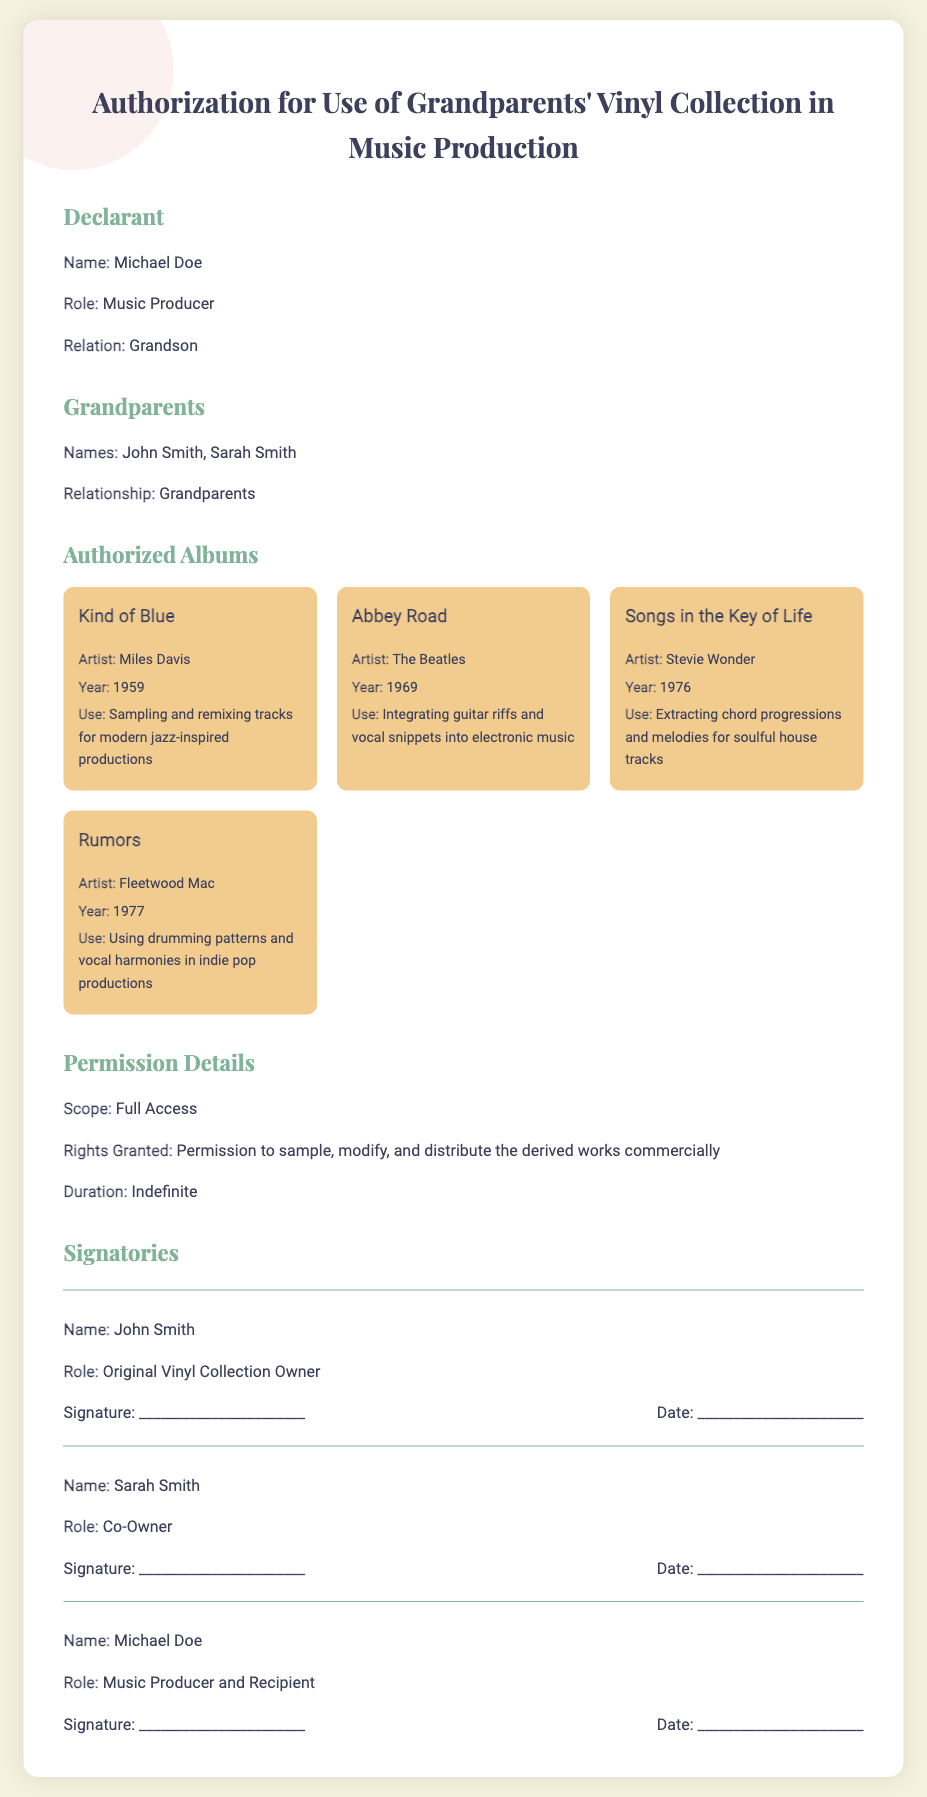What is the name of the declarant? The declarant's name is mentioned at the beginning of the document, Michael Doe.
Answer: Michael Doe Who are the grandparents? The names of the grandparents are listed in their respective section, which includes both John Smith and Sarah Smith.
Answer: John Smith, Sarah Smith What is the release year of the album "Kind of Blue"? The year that "Kind of Blue" was released is specified in the album section of the document, and it is 1959.
Answer: 1959 What type of use is authorized for "Abbey Road"? The use authorized for "Abbey Road" is described in the album details section which states it is for integrating guitar riffs and vocal snippets into electronic music.
Answer: Integrating guitar riffs and vocal snippets What is the scope of the permission granted? The document outlines the permission scope in the permission details section, stating it is full access.
Answer: Full Access What rights are granted regarding the albums? The permissions details state that the rights granted include sampling, modifying, and distributing the derived works commercially.
Answer: Permission to sample, modify, and distribute How many albums are listed in the document? The document details four specific albums, as outlined in the authorized albums section.
Answer: Four What role does Michael Doe have in the signatories section? Michael Doe's role in the signatories is mentioned clearly as the Music Producer and Recipient.
Answer: Music Producer and Recipient What is the duration of the permission granted? The duration of the permission is discussed in the permission details and is noted as indefinite.
Answer: Indefinite 